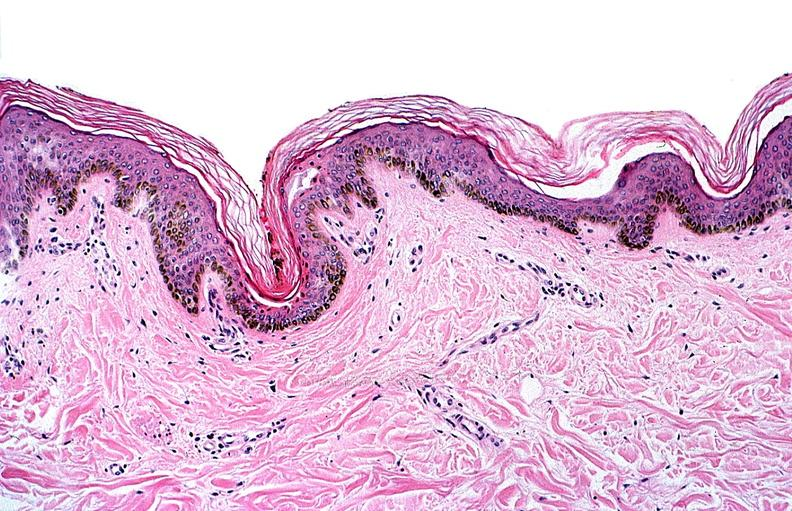where is this?
Answer the question using a single word or phrase. Skin 